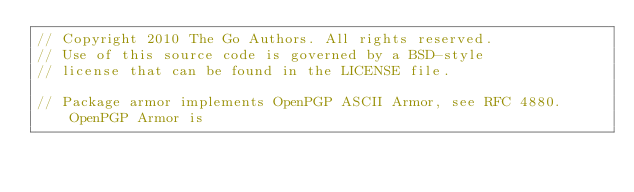<code> <loc_0><loc_0><loc_500><loc_500><_Go_>// Copyright 2010 The Go Authors. All rights reserved.
// Use of this source code is governed by a BSD-style
// license that can be found in the LICENSE file.

// Package armor implements OpenPGP ASCII Armor, see RFC 4880. OpenPGP Armor is</code> 